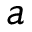<formula> <loc_0><loc_0><loc_500><loc_500>a</formula> 